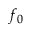Convert formula to latex. <formula><loc_0><loc_0><loc_500><loc_500>f _ { 0 }</formula> 